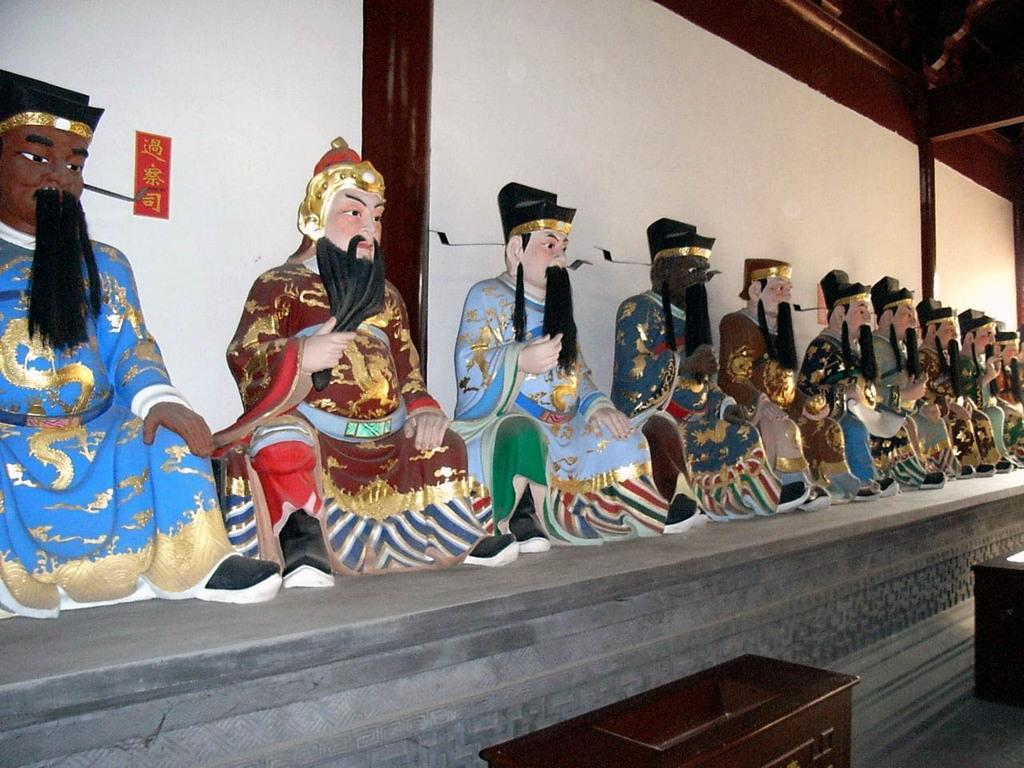What is the main subject of the image? The main subject of the image is many statues. What can be seen in the background of the image? There is a wall in the background of the image. Are there any objects made of wood in the image? Yes, there are wooden boxes in the image. What type of furniture can be seen in the image? There is no furniture present in the image; it features many statues and wooden boxes. How many birds are perched on the statues in the image? There are no birds present in the image. 